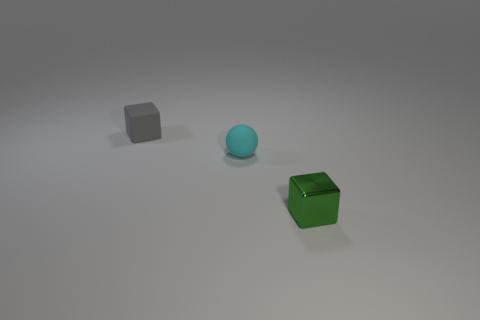Are there any other things that have the same material as the green object?
Your response must be concise. No. Is there anything else that is the same shape as the small cyan object?
Ensure brevity in your answer.  No. Is there any other thing that has the same size as the green metal object?
Keep it short and to the point. Yes. There is a green metal thing; does it have the same shape as the tiny rubber thing behind the ball?
Give a very brief answer. Yes. The small thing that is in front of the small matte thing that is to the right of the block left of the small green thing is what color?
Your response must be concise. Green. What number of objects are tiny rubber things that are right of the gray matte cube or tiny matte objects that are to the right of the rubber block?
Make the answer very short. 1. How many other things are there of the same color as the ball?
Ensure brevity in your answer.  0. Is the shape of the object left of the small sphere the same as  the tiny cyan thing?
Your answer should be very brief. No. Are there fewer cubes that are behind the tiny cyan matte object than tiny green shiny cubes?
Provide a short and direct response. No. Is there a small cube made of the same material as the sphere?
Offer a terse response. Yes. 